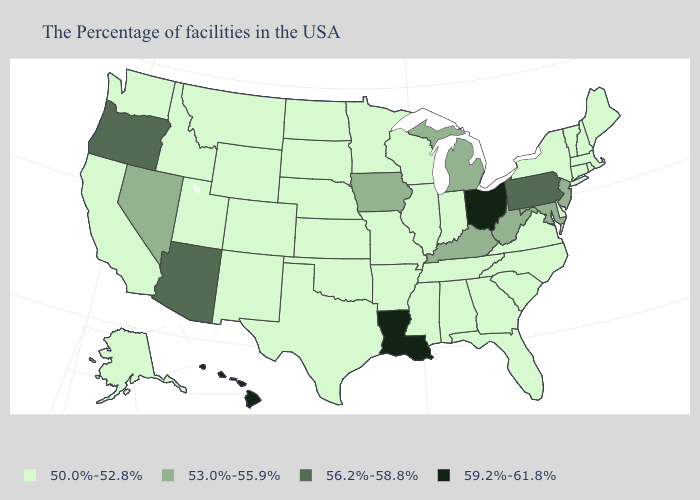What is the value of Missouri?
Answer briefly. 50.0%-52.8%. Does the first symbol in the legend represent the smallest category?
Be succinct. Yes. What is the lowest value in the Northeast?
Be succinct. 50.0%-52.8%. Among the states that border California , which have the lowest value?
Concise answer only. Nevada. What is the highest value in the USA?
Write a very short answer. 59.2%-61.8%. Among the states that border New Mexico , which have the lowest value?
Answer briefly. Oklahoma, Texas, Colorado, Utah. Name the states that have a value in the range 53.0%-55.9%?
Give a very brief answer. New Jersey, Maryland, West Virginia, Michigan, Kentucky, Iowa, Nevada. What is the value of Utah?
Write a very short answer. 50.0%-52.8%. Which states hav the highest value in the South?
Keep it brief. Louisiana. Does Pennsylvania have the same value as Texas?
Concise answer only. No. Does Massachusetts have the lowest value in the Northeast?
Quick response, please. Yes. What is the highest value in the USA?
Give a very brief answer. 59.2%-61.8%. What is the value of Alaska?
Keep it brief. 50.0%-52.8%. Name the states that have a value in the range 56.2%-58.8%?
Write a very short answer. Pennsylvania, Arizona, Oregon. Which states hav the highest value in the South?
Concise answer only. Louisiana. 